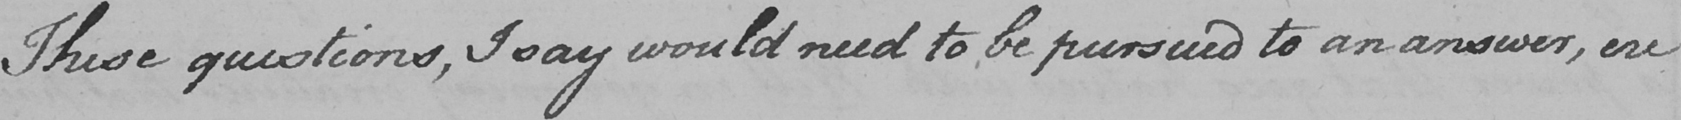What is written in this line of handwriting? These questions , I say would need to be pursued to an answer , ere 